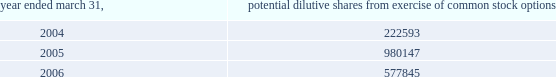Abiomed , inc .
And subsidiaries notes to consolidated financial statements 2014 ( continued ) the calculation of diluted weighted-average shares outstanding for the fiscal years ended march 31 , 2004 , 2005 and 2006 excludes potential stock from unexercised stock options that have an exercise price below the average market price as shown below .
Year ended march 31 , potential dilutive shares from exercise of common stock options .
The calculation of diluted weighted average shares outstanding excludes unissued shares of common stock associated with outstanding stock options that have exercise prices greater than the average market price .
For the fiscal years ending march 31 , 2004 , 2005 and 2006 , the weighted average number of these potential shares totaled 1908347 , 825014 and 1417130 shares , respectively .
The calculation of diluted weighted average shares outstanding for these fiscal years also excludes warrants to purchase 400000 share of common stock issued in connection with the acquisition of intellectual property ( see note 5 ) .
( k ) cash and cash equivalents the company classifies any marketable security with a maturity date of 90 days or less at the time of purchase as a cash equivalent .
At march 31 , 2005 and march 31 , 2006 , the company had restricted cash of approximately $ 97000 and $ 261000 , respectively , which are included in other assets at march 31 , 2005 and prepaid expenses and other current assets at march 31 , 2006 , respectively .
This cash represents security deposits held in the company 2019s european banks for certain facility and auto leases .
( l ) marketable securities and long-term investments the company classifies any security with a maturity date of greater than 90 days at the time of purchase as marketable securities and classifies marketable securities with a maturity date of greater than one year from the balance sheet date as long-term investments based upon the ability and intent of the company .
In accordance with statement of financial accounting standards ( sfas ) no .
115 , accounting for certain investments in debt and equity securities , securities that the company has the positive intent and ability to hold to maturity are reported at amortized cost and classified as held-to-maturity securities .
At march 31 , 2006 the held-to-maturity investment portfolio consisted primarily of government securities and corporate bonds with maturities of one year or less .
The amortized cost , including interest receivable , and market value of held 2013to-maturity short-term marketable securities were approximately $ 29669000 and $ 29570000 at march 31 , 2005 , and $ 16901000 and $ 16866000 at march 31 , 2006 , respectively .
The company has classified its portion of the investment portfolio consisting of corporate asset-backed securities as available-for 2013sale securities .
The cost of these securities approximates market value and was $ 4218000 at march 31 , 2005 and $ 6102000 at march 31 , 2006 .
Principal payments of these available-for-sale securities are typically made on an expected pre-determined basis rather than on the longer contractual maturity date. .
For the available-for 2013sale securities , what is the unrealized gain or loss at march 31 , 2005? 
Computations: (4218000 - 4218000)
Answer: 0.0. 